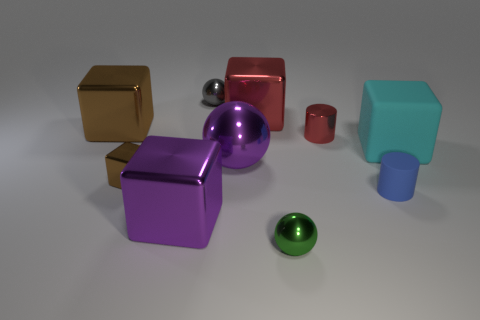Is the cyan cube made of the same material as the block behind the big brown metal cube?
Offer a terse response. No. The tiny matte cylinder is what color?
Give a very brief answer. Blue. There is a tiny metallic ball that is behind the tiny sphere on the right side of the gray metal thing; how many cyan things are on the left side of it?
Give a very brief answer. 0. Are there any small gray objects in front of the big brown cube?
Ensure brevity in your answer.  No. How many red cylinders have the same material as the tiny brown block?
Make the answer very short. 1. What number of things are small green objects or big cyan blocks?
Offer a terse response. 2. Is there a brown cube?
Your answer should be very brief. Yes. What is the small cylinder to the right of the small cylinder that is behind the small cylinder on the right side of the red cylinder made of?
Provide a short and direct response. Rubber. Is the number of purple metallic cubes behind the big cyan cube less than the number of green metallic spheres?
Offer a very short reply. Yes. What material is the green thing that is the same size as the gray metal object?
Provide a succinct answer. Metal. 